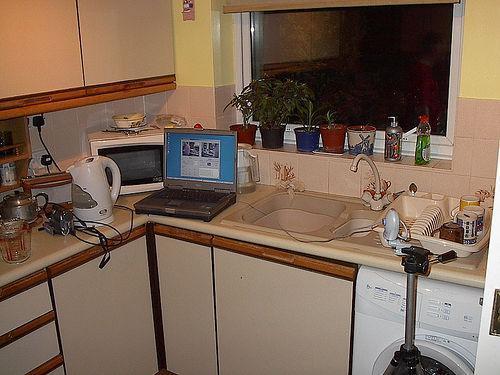How many plants do they have?
Give a very brief answer. 5. How many upper level cabinets are there?
Give a very brief answer. 2. How many plants are there?
Give a very brief answer. 4. How many laptops are visible?
Give a very brief answer. 1. 